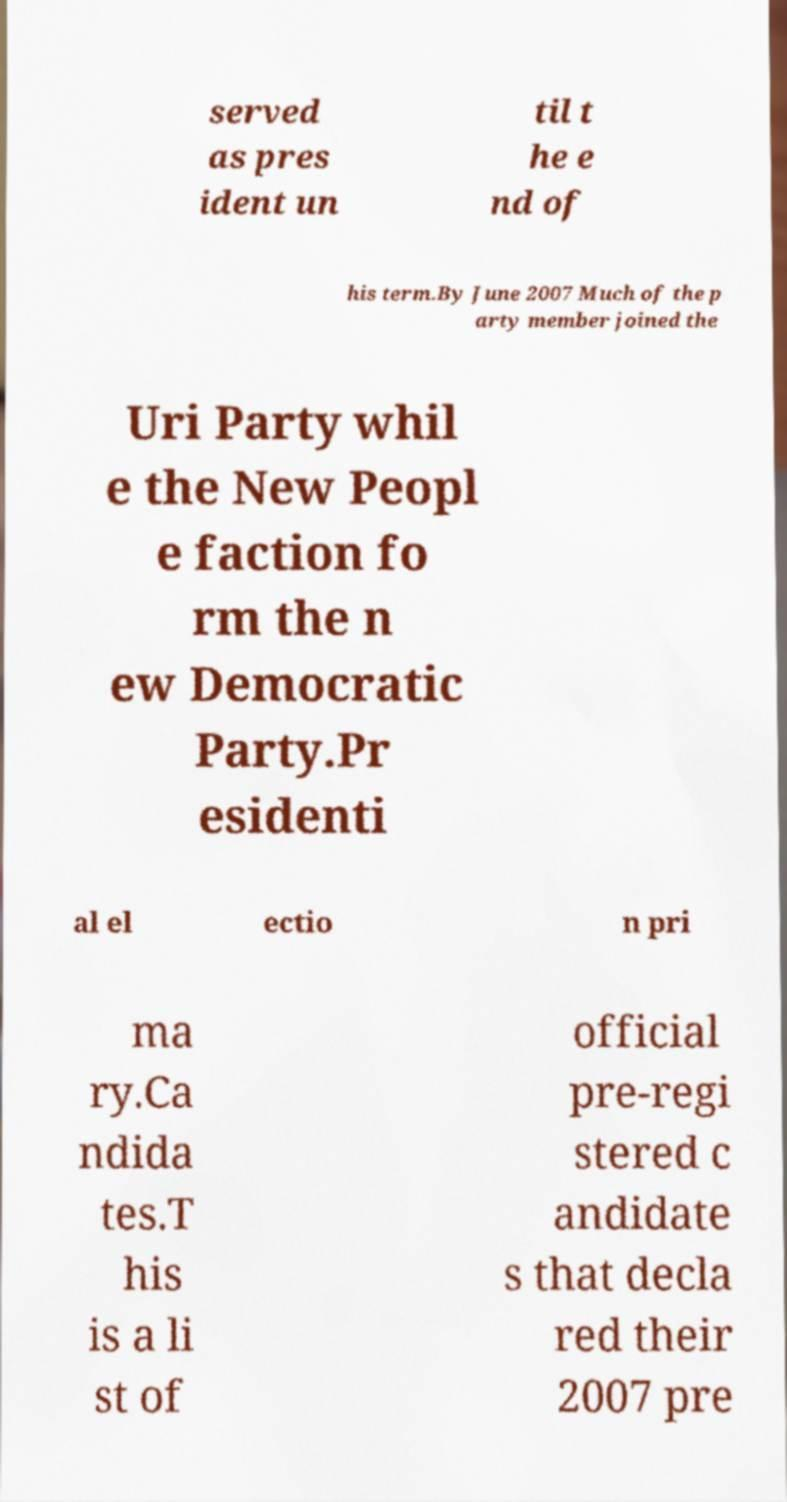I need the written content from this picture converted into text. Can you do that? served as pres ident un til t he e nd of his term.By June 2007 Much of the p arty member joined the Uri Party whil e the New Peopl e faction fo rm the n ew Democratic Party.Pr esidenti al el ectio n pri ma ry.Ca ndida tes.T his is a li st of official pre-regi stered c andidate s that decla red their 2007 pre 